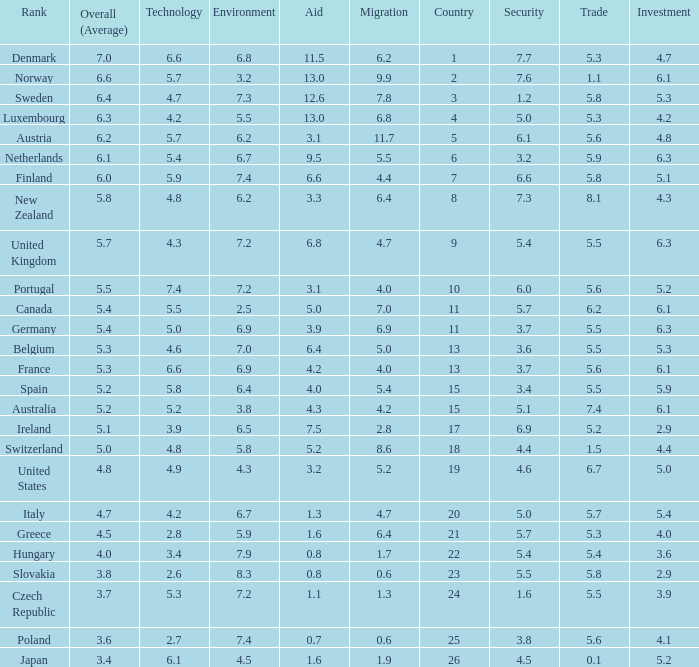What is the migration rating when trade is 5.7? 4.7. 